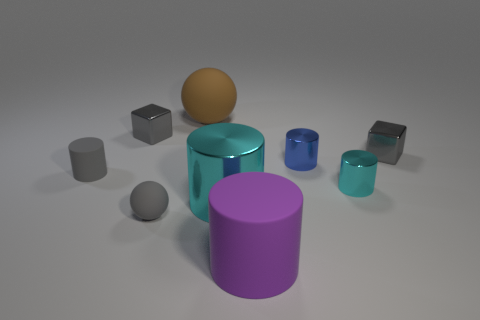The large metallic thing has what shape?
Give a very brief answer. Cylinder. Is there anything else that is the same size as the gray rubber cylinder?
Your answer should be compact. Yes. Are there more tiny spheres that are behind the brown ball than big blue shiny spheres?
Give a very brief answer. No. What shape is the rubber object behind the gray block that is on the left side of the large purple thing that is in front of the gray matte cylinder?
Give a very brief answer. Sphere. There is a rubber thing that is behind the blue thing; is it the same size as the large cyan cylinder?
Ensure brevity in your answer.  Yes. The small gray thing that is both on the left side of the tiny ball and behind the gray rubber cylinder has what shape?
Your answer should be very brief. Cube. There is a small matte ball; is it the same color as the cylinder in front of the big cyan cylinder?
Provide a short and direct response. No. What color is the tiny shiny cylinder behind the small cyan thing that is on the right side of the tiny gray shiny object that is to the left of the brown sphere?
Offer a very short reply. Blue. What color is the other small metal thing that is the same shape as the small blue object?
Your answer should be very brief. Cyan. Are there an equal number of gray objects that are in front of the purple cylinder and tiny cyan matte balls?
Make the answer very short. Yes. 